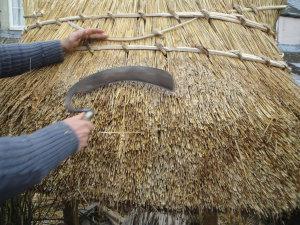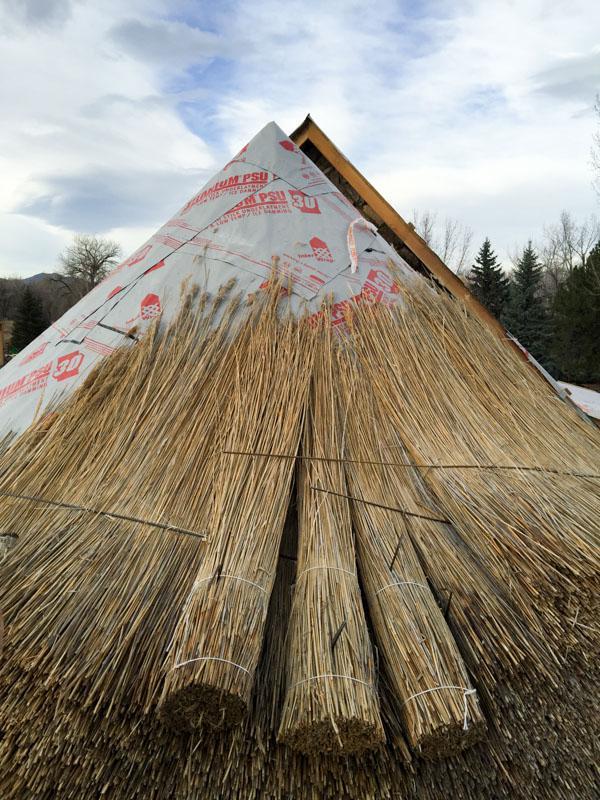The first image is the image on the left, the second image is the image on the right. For the images shown, is this caption "An image includes several roll-shaped tied bundles of thatch laying on an unfinished roof without a ladder propped against it." true? Answer yes or no. Yes. The first image is the image on the left, the second image is the image on the right. Examine the images to the left and right. Is the description "At least one ladder is touching the thatch." accurate? Answer yes or no. No. 